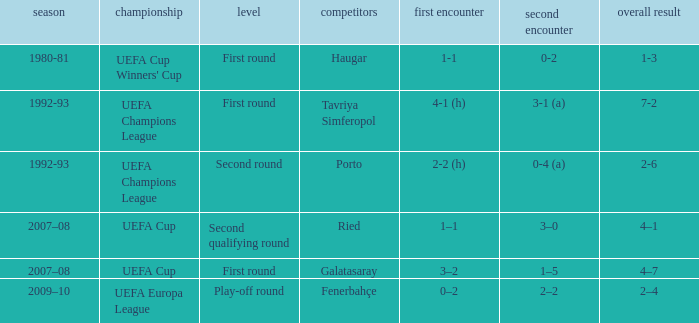 what's the 1st leg where opponents is galatasaray 3–2. 